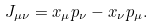Convert formula to latex. <formula><loc_0><loc_0><loc_500><loc_500>J _ { \mu \nu } = x _ { \mu } p _ { \nu } - x _ { \nu } p _ { \mu } .</formula> 